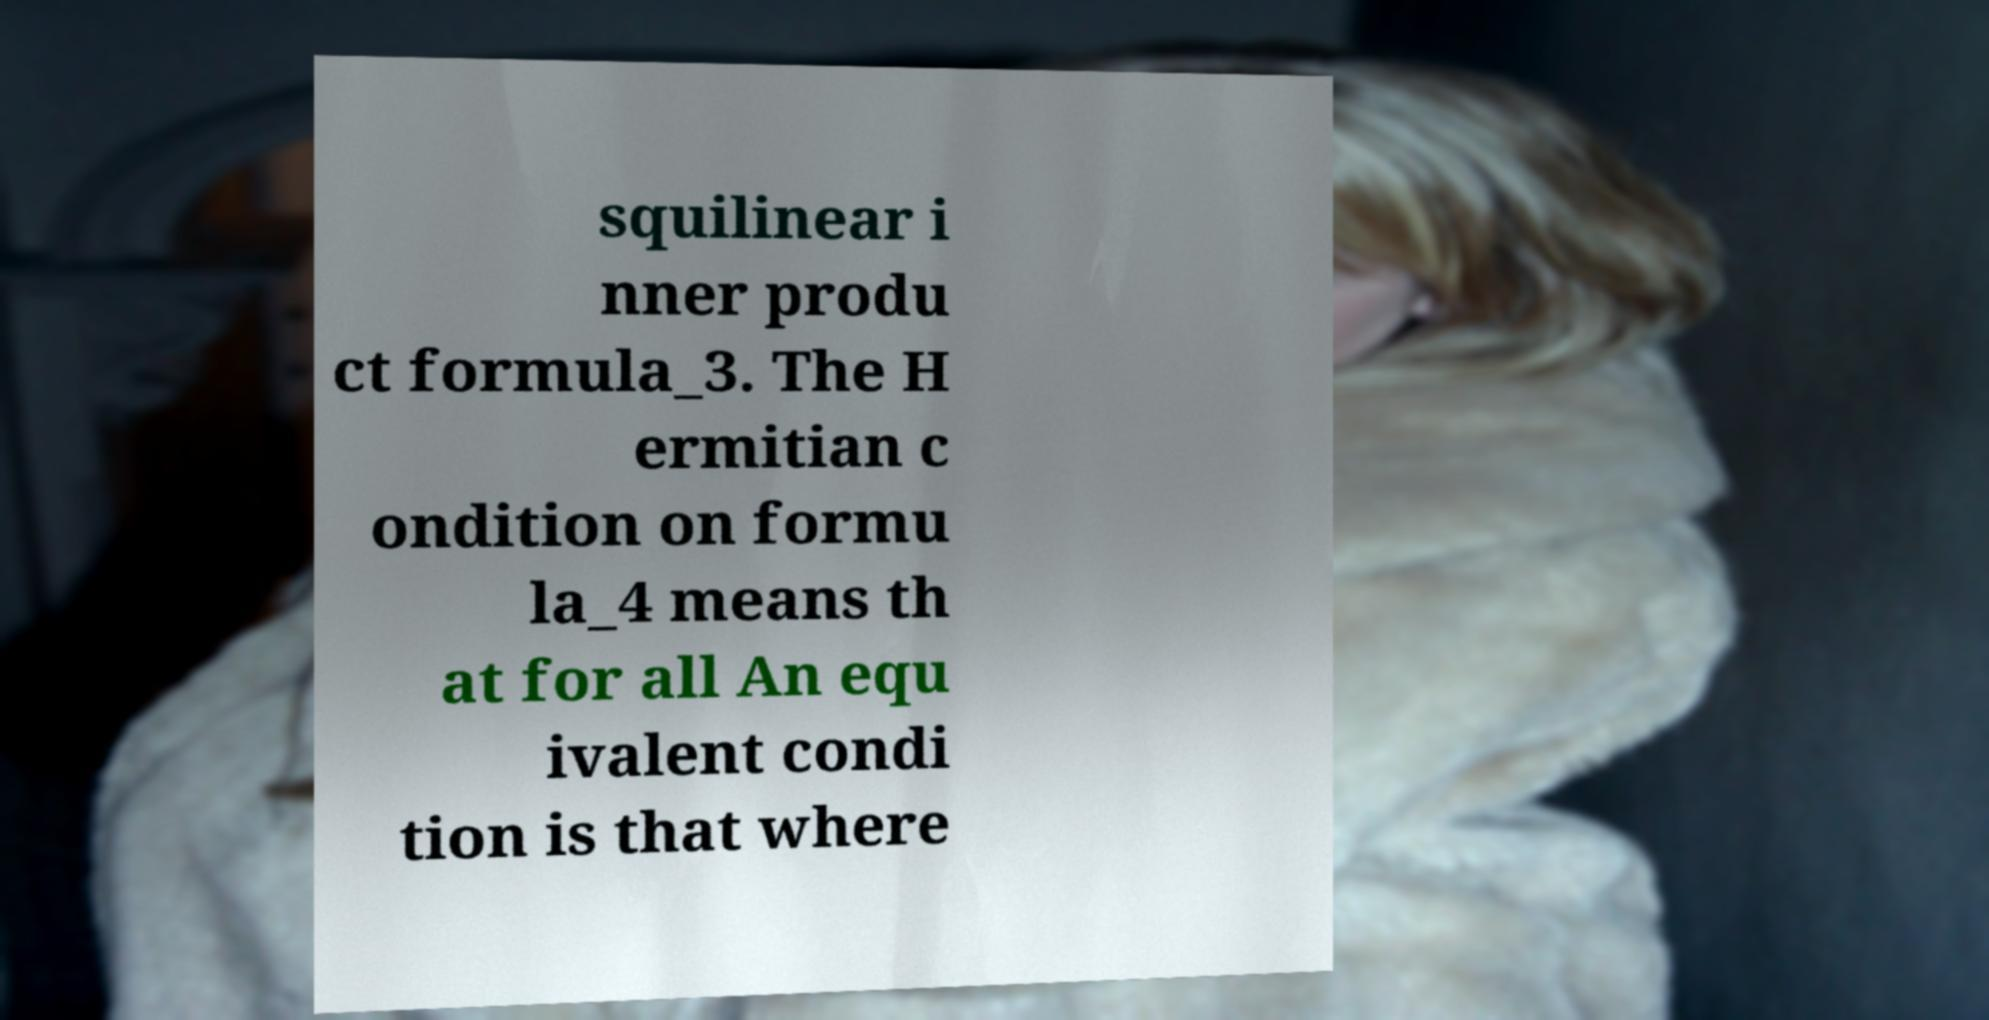What messages or text are displayed in this image? I need them in a readable, typed format. squilinear i nner produ ct formula_3. The H ermitian c ondition on formu la_4 means th at for all An equ ivalent condi tion is that where 